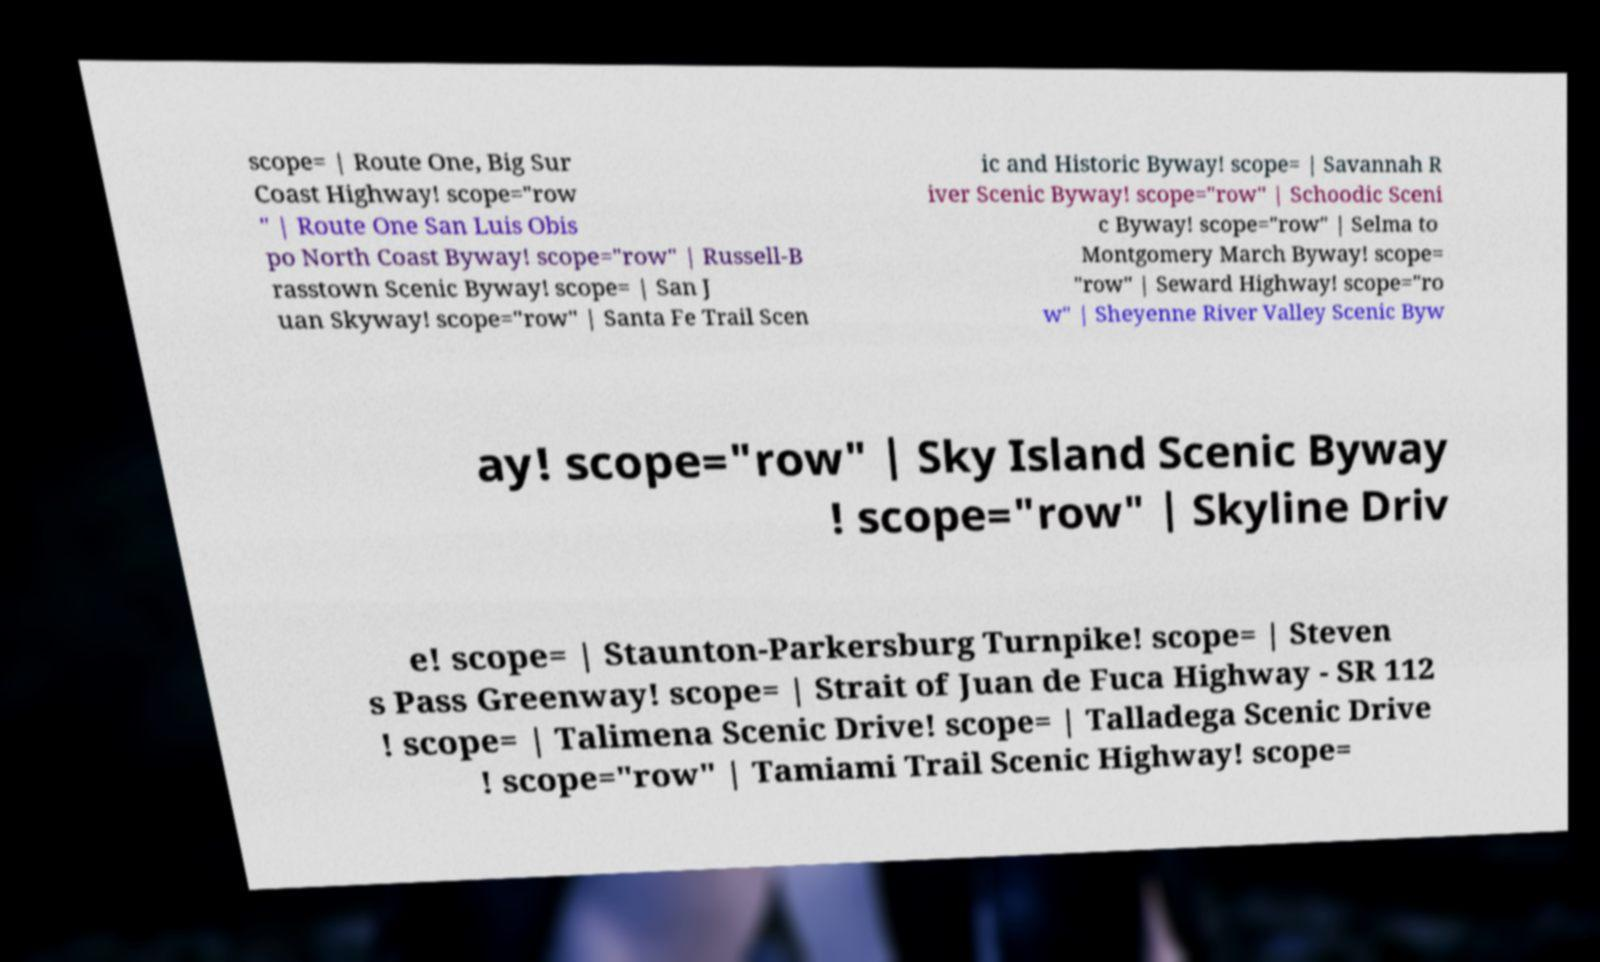Can you accurately transcribe the text from the provided image for me? scope= | Route One, Big Sur Coast Highway! scope="row " | Route One San Luis Obis po North Coast Byway! scope="row" | Russell-B rasstown Scenic Byway! scope= | San J uan Skyway! scope="row" | Santa Fe Trail Scen ic and Historic Byway! scope= | Savannah R iver Scenic Byway! scope="row" | Schoodic Sceni c Byway! scope="row" | Selma to Montgomery March Byway! scope= "row" | Seward Highway! scope="ro w" | Sheyenne River Valley Scenic Byw ay! scope="row" | Sky Island Scenic Byway ! scope="row" | Skyline Driv e! scope= | Staunton-Parkersburg Turnpike! scope= | Steven s Pass Greenway! scope= | Strait of Juan de Fuca Highway - SR 112 ! scope= | Talimena Scenic Drive! scope= | Talladega Scenic Drive ! scope="row" | Tamiami Trail Scenic Highway! scope= 